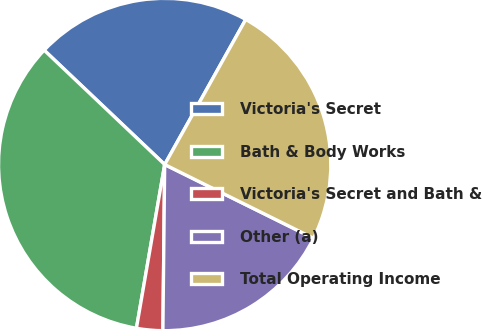<chart> <loc_0><loc_0><loc_500><loc_500><pie_chart><fcel>Victoria's Secret<fcel>Bath & Body Works<fcel>Victoria's Secret and Bath &<fcel>Other (a)<fcel>Total Operating Income<nl><fcel>21.03%<fcel>34.36%<fcel>2.55%<fcel>17.85%<fcel>24.21%<nl></chart> 